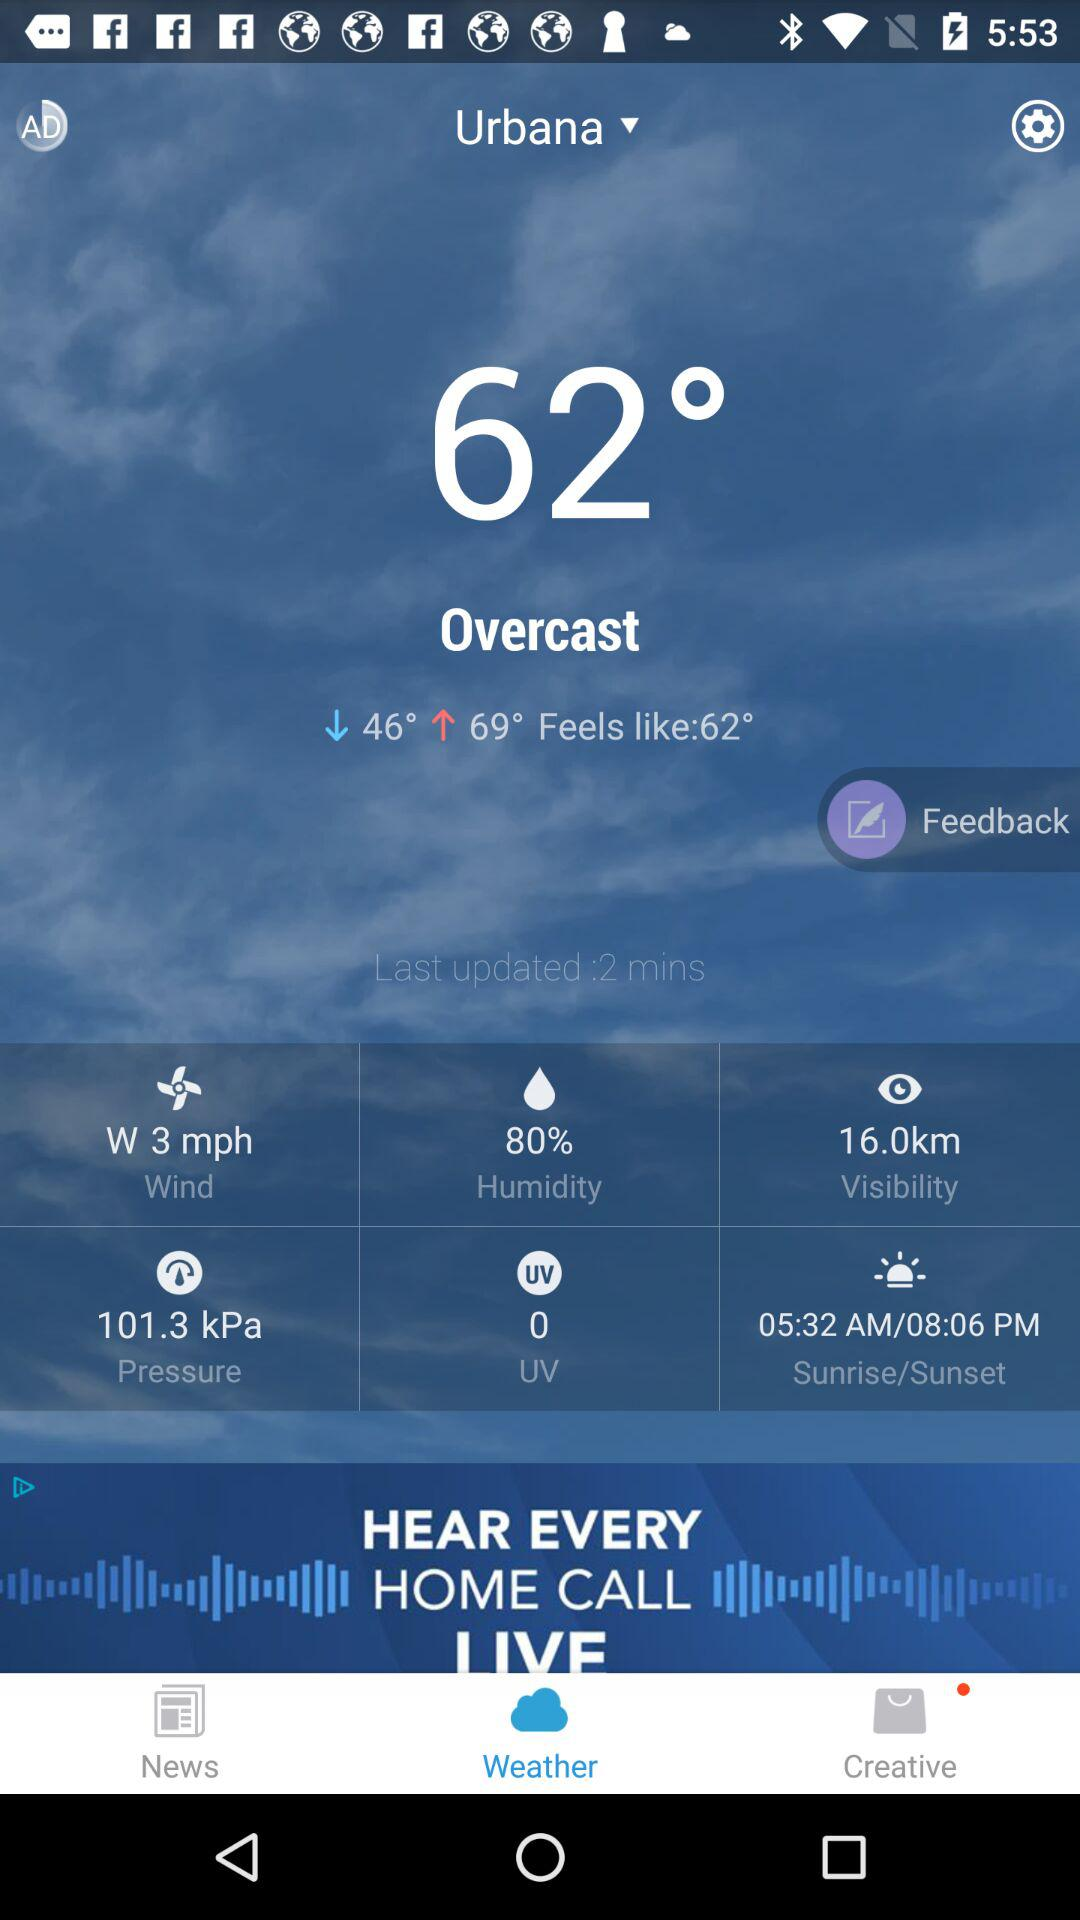What is the humidity percentage?
Answer the question using a single word or phrase. 80% 